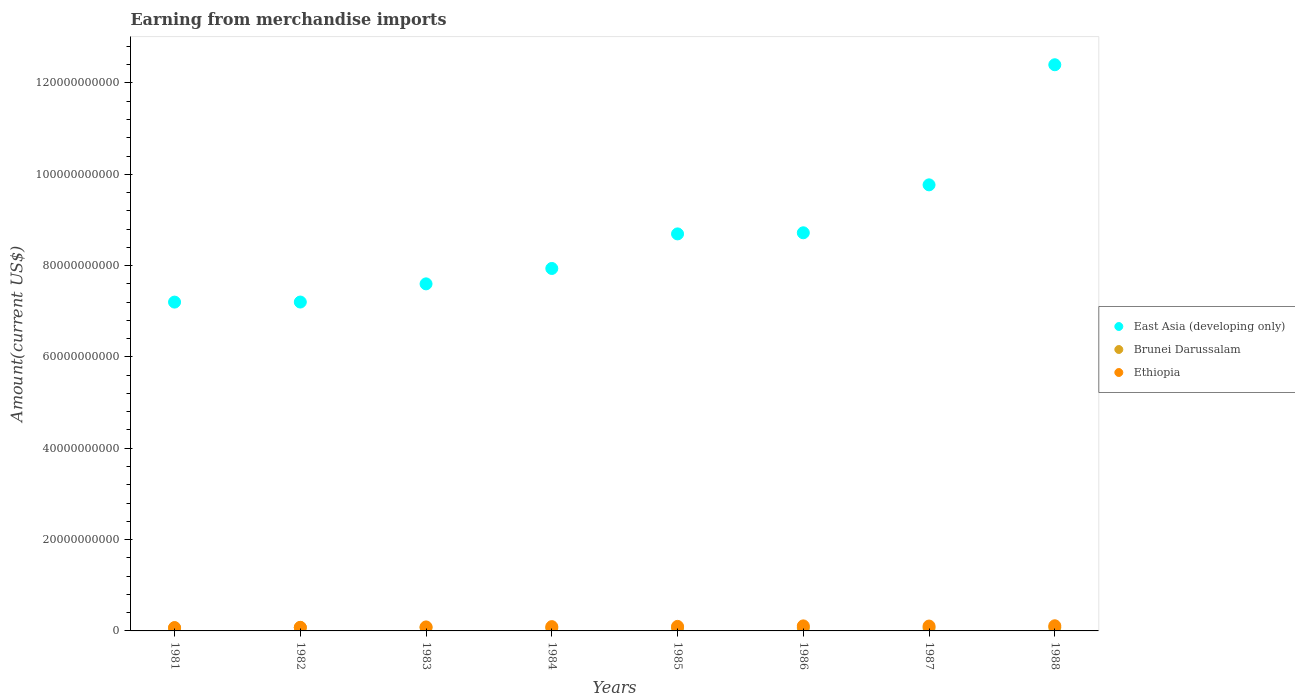How many different coloured dotlines are there?
Provide a short and direct response. 3. What is the amount earned from merchandise imports in East Asia (developing only) in 1982?
Your answer should be compact. 7.20e+1. Across all years, what is the maximum amount earned from merchandise imports in Ethiopia?
Offer a very short reply. 1.13e+09. Across all years, what is the minimum amount earned from merchandise imports in Ethiopia?
Make the answer very short. 7.39e+08. In which year was the amount earned from merchandise imports in Brunei Darussalam maximum?
Your answer should be compact. 1988. In which year was the amount earned from merchandise imports in Ethiopia minimum?
Your response must be concise. 1981. What is the total amount earned from merchandise imports in Ethiopia in the graph?
Your answer should be very brief. 7.63e+09. What is the difference between the amount earned from merchandise imports in Brunei Darussalam in 1981 and that in 1983?
Make the answer very short. -1.30e+08. What is the difference between the amount earned from merchandise imports in East Asia (developing only) in 1984 and the amount earned from merchandise imports in Brunei Darussalam in 1983?
Provide a short and direct response. 7.86e+1. What is the average amount earned from merchandise imports in Ethiopia per year?
Your answer should be very brief. 9.54e+08. In the year 1981, what is the difference between the amount earned from merchandise imports in Brunei Darussalam and amount earned from merchandise imports in East Asia (developing only)?
Your answer should be compact. -7.14e+1. In how many years, is the amount earned from merchandise imports in Brunei Darussalam greater than 16000000000 US$?
Offer a very short reply. 0. What is the ratio of the amount earned from merchandise imports in Brunei Darussalam in 1981 to that in 1983?
Offer a terse response. 0.82. What is the difference between the highest and the second highest amount earned from merchandise imports in East Asia (developing only)?
Offer a very short reply. 2.63e+1. What is the difference between the highest and the lowest amount earned from merchandise imports in Brunei Darussalam?
Your answer should be very brief. 1.50e+08. Is the sum of the amount earned from merchandise imports in East Asia (developing only) in 1981 and 1983 greater than the maximum amount earned from merchandise imports in Ethiopia across all years?
Offer a terse response. Yes. Is it the case that in every year, the sum of the amount earned from merchandise imports in Ethiopia and amount earned from merchandise imports in East Asia (developing only)  is greater than the amount earned from merchandise imports in Brunei Darussalam?
Your answer should be compact. Yes. Is the amount earned from merchandise imports in Brunei Darussalam strictly greater than the amount earned from merchandise imports in Ethiopia over the years?
Your response must be concise. No. Does the graph contain grids?
Provide a succinct answer. No. How are the legend labels stacked?
Provide a succinct answer. Vertical. What is the title of the graph?
Make the answer very short. Earning from merchandise imports. What is the label or title of the X-axis?
Your answer should be compact. Years. What is the label or title of the Y-axis?
Keep it short and to the point. Amount(current US$). What is the Amount(current US$) of East Asia (developing only) in 1981?
Provide a succinct answer. 7.20e+1. What is the Amount(current US$) of Brunei Darussalam in 1981?
Keep it short and to the point. 5.94e+08. What is the Amount(current US$) of Ethiopia in 1981?
Provide a short and direct response. 7.39e+08. What is the Amount(current US$) in East Asia (developing only) in 1982?
Your answer should be compact. 7.20e+1. What is the Amount(current US$) of Brunei Darussalam in 1982?
Give a very brief answer. 7.31e+08. What is the Amount(current US$) in Ethiopia in 1982?
Your response must be concise. 7.86e+08. What is the Amount(current US$) of East Asia (developing only) in 1983?
Offer a terse response. 7.60e+1. What is the Amount(current US$) of Brunei Darussalam in 1983?
Offer a very short reply. 7.24e+08. What is the Amount(current US$) in Ethiopia in 1983?
Ensure brevity in your answer.  8.75e+08. What is the Amount(current US$) in East Asia (developing only) in 1984?
Keep it short and to the point. 7.94e+1. What is the Amount(current US$) of Brunei Darussalam in 1984?
Provide a short and direct response. 6.26e+08. What is the Amount(current US$) of Ethiopia in 1984?
Provide a succinct answer. 9.42e+08. What is the Amount(current US$) in East Asia (developing only) in 1985?
Give a very brief answer. 8.69e+1. What is the Amount(current US$) in Brunei Darussalam in 1985?
Provide a succinct answer. 6.15e+08. What is the Amount(current US$) in Ethiopia in 1985?
Offer a terse response. 9.93e+08. What is the Amount(current US$) of East Asia (developing only) in 1986?
Provide a succinct answer. 8.72e+1. What is the Amount(current US$) of Brunei Darussalam in 1986?
Offer a very short reply. 6.56e+08. What is the Amount(current US$) of Ethiopia in 1986?
Your answer should be very brief. 1.10e+09. What is the Amount(current US$) of East Asia (developing only) in 1987?
Your answer should be very brief. 9.77e+1. What is the Amount(current US$) of Brunei Darussalam in 1987?
Give a very brief answer. 6.41e+08. What is the Amount(current US$) in Ethiopia in 1987?
Your answer should be compact. 1.07e+09. What is the Amount(current US$) of East Asia (developing only) in 1988?
Keep it short and to the point. 1.24e+11. What is the Amount(current US$) of Brunei Darussalam in 1988?
Your response must be concise. 7.44e+08. What is the Amount(current US$) of Ethiopia in 1988?
Your answer should be compact. 1.13e+09. Across all years, what is the maximum Amount(current US$) of East Asia (developing only)?
Ensure brevity in your answer.  1.24e+11. Across all years, what is the maximum Amount(current US$) of Brunei Darussalam?
Your answer should be very brief. 7.44e+08. Across all years, what is the maximum Amount(current US$) of Ethiopia?
Make the answer very short. 1.13e+09. Across all years, what is the minimum Amount(current US$) in East Asia (developing only)?
Provide a succinct answer. 7.20e+1. Across all years, what is the minimum Amount(current US$) of Brunei Darussalam?
Offer a very short reply. 5.94e+08. Across all years, what is the minimum Amount(current US$) of Ethiopia?
Make the answer very short. 7.39e+08. What is the total Amount(current US$) of East Asia (developing only) in the graph?
Your response must be concise. 6.95e+11. What is the total Amount(current US$) in Brunei Darussalam in the graph?
Your response must be concise. 5.33e+09. What is the total Amount(current US$) of Ethiopia in the graph?
Keep it short and to the point. 7.63e+09. What is the difference between the Amount(current US$) of East Asia (developing only) in 1981 and that in 1982?
Your answer should be compact. -1.40e+07. What is the difference between the Amount(current US$) of Brunei Darussalam in 1981 and that in 1982?
Offer a terse response. -1.37e+08. What is the difference between the Amount(current US$) of Ethiopia in 1981 and that in 1982?
Provide a succinct answer. -4.70e+07. What is the difference between the Amount(current US$) of East Asia (developing only) in 1981 and that in 1983?
Offer a very short reply. -3.99e+09. What is the difference between the Amount(current US$) of Brunei Darussalam in 1981 and that in 1983?
Ensure brevity in your answer.  -1.30e+08. What is the difference between the Amount(current US$) in Ethiopia in 1981 and that in 1983?
Offer a terse response. -1.36e+08. What is the difference between the Amount(current US$) of East Asia (developing only) in 1981 and that in 1984?
Offer a terse response. -7.37e+09. What is the difference between the Amount(current US$) in Brunei Darussalam in 1981 and that in 1984?
Give a very brief answer. -3.20e+07. What is the difference between the Amount(current US$) of Ethiopia in 1981 and that in 1984?
Your answer should be very brief. -2.03e+08. What is the difference between the Amount(current US$) in East Asia (developing only) in 1981 and that in 1985?
Provide a succinct answer. -1.49e+1. What is the difference between the Amount(current US$) of Brunei Darussalam in 1981 and that in 1985?
Keep it short and to the point. -2.10e+07. What is the difference between the Amount(current US$) of Ethiopia in 1981 and that in 1985?
Make the answer very short. -2.54e+08. What is the difference between the Amount(current US$) in East Asia (developing only) in 1981 and that in 1986?
Keep it short and to the point. -1.52e+1. What is the difference between the Amount(current US$) of Brunei Darussalam in 1981 and that in 1986?
Keep it short and to the point. -6.20e+07. What is the difference between the Amount(current US$) in Ethiopia in 1981 and that in 1986?
Your response must be concise. -3.63e+08. What is the difference between the Amount(current US$) in East Asia (developing only) in 1981 and that in 1987?
Offer a very short reply. -2.57e+1. What is the difference between the Amount(current US$) of Brunei Darussalam in 1981 and that in 1987?
Ensure brevity in your answer.  -4.70e+07. What is the difference between the Amount(current US$) in Ethiopia in 1981 and that in 1987?
Keep it short and to the point. -3.27e+08. What is the difference between the Amount(current US$) of East Asia (developing only) in 1981 and that in 1988?
Offer a terse response. -5.20e+1. What is the difference between the Amount(current US$) in Brunei Darussalam in 1981 and that in 1988?
Offer a very short reply. -1.50e+08. What is the difference between the Amount(current US$) in Ethiopia in 1981 and that in 1988?
Give a very brief answer. -3.90e+08. What is the difference between the Amount(current US$) of East Asia (developing only) in 1982 and that in 1983?
Your answer should be compact. -3.98e+09. What is the difference between the Amount(current US$) of Brunei Darussalam in 1982 and that in 1983?
Your response must be concise. 7.00e+06. What is the difference between the Amount(current US$) in Ethiopia in 1982 and that in 1983?
Your answer should be very brief. -8.90e+07. What is the difference between the Amount(current US$) in East Asia (developing only) in 1982 and that in 1984?
Offer a terse response. -7.35e+09. What is the difference between the Amount(current US$) of Brunei Darussalam in 1982 and that in 1984?
Provide a short and direct response. 1.05e+08. What is the difference between the Amount(current US$) of Ethiopia in 1982 and that in 1984?
Make the answer very short. -1.56e+08. What is the difference between the Amount(current US$) of East Asia (developing only) in 1982 and that in 1985?
Provide a short and direct response. -1.49e+1. What is the difference between the Amount(current US$) of Brunei Darussalam in 1982 and that in 1985?
Offer a very short reply. 1.16e+08. What is the difference between the Amount(current US$) in Ethiopia in 1982 and that in 1985?
Your answer should be compact. -2.07e+08. What is the difference between the Amount(current US$) of East Asia (developing only) in 1982 and that in 1986?
Provide a succinct answer. -1.52e+1. What is the difference between the Amount(current US$) in Brunei Darussalam in 1982 and that in 1986?
Offer a terse response. 7.50e+07. What is the difference between the Amount(current US$) of Ethiopia in 1982 and that in 1986?
Provide a short and direct response. -3.16e+08. What is the difference between the Amount(current US$) of East Asia (developing only) in 1982 and that in 1987?
Ensure brevity in your answer.  -2.57e+1. What is the difference between the Amount(current US$) of Brunei Darussalam in 1982 and that in 1987?
Your response must be concise. 9.00e+07. What is the difference between the Amount(current US$) in Ethiopia in 1982 and that in 1987?
Your answer should be compact. -2.80e+08. What is the difference between the Amount(current US$) in East Asia (developing only) in 1982 and that in 1988?
Offer a very short reply. -5.20e+1. What is the difference between the Amount(current US$) in Brunei Darussalam in 1982 and that in 1988?
Ensure brevity in your answer.  -1.30e+07. What is the difference between the Amount(current US$) in Ethiopia in 1982 and that in 1988?
Offer a very short reply. -3.43e+08. What is the difference between the Amount(current US$) in East Asia (developing only) in 1983 and that in 1984?
Your answer should be very brief. -3.37e+09. What is the difference between the Amount(current US$) of Brunei Darussalam in 1983 and that in 1984?
Provide a succinct answer. 9.80e+07. What is the difference between the Amount(current US$) in Ethiopia in 1983 and that in 1984?
Your response must be concise. -6.70e+07. What is the difference between the Amount(current US$) in East Asia (developing only) in 1983 and that in 1985?
Keep it short and to the point. -1.09e+1. What is the difference between the Amount(current US$) in Brunei Darussalam in 1983 and that in 1985?
Keep it short and to the point. 1.09e+08. What is the difference between the Amount(current US$) of Ethiopia in 1983 and that in 1985?
Offer a very short reply. -1.18e+08. What is the difference between the Amount(current US$) in East Asia (developing only) in 1983 and that in 1986?
Provide a succinct answer. -1.12e+1. What is the difference between the Amount(current US$) in Brunei Darussalam in 1983 and that in 1986?
Offer a terse response. 6.80e+07. What is the difference between the Amount(current US$) of Ethiopia in 1983 and that in 1986?
Provide a short and direct response. -2.27e+08. What is the difference between the Amount(current US$) of East Asia (developing only) in 1983 and that in 1987?
Offer a very short reply. -2.17e+1. What is the difference between the Amount(current US$) of Brunei Darussalam in 1983 and that in 1987?
Keep it short and to the point. 8.30e+07. What is the difference between the Amount(current US$) of Ethiopia in 1983 and that in 1987?
Make the answer very short. -1.91e+08. What is the difference between the Amount(current US$) in East Asia (developing only) in 1983 and that in 1988?
Offer a terse response. -4.80e+1. What is the difference between the Amount(current US$) of Brunei Darussalam in 1983 and that in 1988?
Offer a very short reply. -2.00e+07. What is the difference between the Amount(current US$) of Ethiopia in 1983 and that in 1988?
Offer a terse response. -2.54e+08. What is the difference between the Amount(current US$) in East Asia (developing only) in 1984 and that in 1985?
Keep it short and to the point. -7.57e+09. What is the difference between the Amount(current US$) in Brunei Darussalam in 1984 and that in 1985?
Your answer should be compact. 1.10e+07. What is the difference between the Amount(current US$) of Ethiopia in 1984 and that in 1985?
Ensure brevity in your answer.  -5.10e+07. What is the difference between the Amount(current US$) in East Asia (developing only) in 1984 and that in 1986?
Make the answer very short. -7.81e+09. What is the difference between the Amount(current US$) of Brunei Darussalam in 1984 and that in 1986?
Offer a very short reply. -3.00e+07. What is the difference between the Amount(current US$) in Ethiopia in 1984 and that in 1986?
Provide a succinct answer. -1.60e+08. What is the difference between the Amount(current US$) of East Asia (developing only) in 1984 and that in 1987?
Your answer should be compact. -1.83e+1. What is the difference between the Amount(current US$) of Brunei Darussalam in 1984 and that in 1987?
Offer a very short reply. -1.50e+07. What is the difference between the Amount(current US$) of Ethiopia in 1984 and that in 1987?
Give a very brief answer. -1.24e+08. What is the difference between the Amount(current US$) in East Asia (developing only) in 1984 and that in 1988?
Keep it short and to the point. -4.46e+1. What is the difference between the Amount(current US$) in Brunei Darussalam in 1984 and that in 1988?
Provide a short and direct response. -1.18e+08. What is the difference between the Amount(current US$) in Ethiopia in 1984 and that in 1988?
Provide a short and direct response. -1.87e+08. What is the difference between the Amount(current US$) of East Asia (developing only) in 1985 and that in 1986?
Make the answer very short. -2.43e+08. What is the difference between the Amount(current US$) in Brunei Darussalam in 1985 and that in 1986?
Your answer should be compact. -4.10e+07. What is the difference between the Amount(current US$) of Ethiopia in 1985 and that in 1986?
Offer a terse response. -1.09e+08. What is the difference between the Amount(current US$) of East Asia (developing only) in 1985 and that in 1987?
Give a very brief answer. -1.07e+1. What is the difference between the Amount(current US$) in Brunei Darussalam in 1985 and that in 1987?
Keep it short and to the point. -2.60e+07. What is the difference between the Amount(current US$) of Ethiopia in 1985 and that in 1987?
Keep it short and to the point. -7.30e+07. What is the difference between the Amount(current US$) in East Asia (developing only) in 1985 and that in 1988?
Give a very brief answer. -3.70e+1. What is the difference between the Amount(current US$) in Brunei Darussalam in 1985 and that in 1988?
Your response must be concise. -1.29e+08. What is the difference between the Amount(current US$) in Ethiopia in 1985 and that in 1988?
Provide a succinct answer. -1.36e+08. What is the difference between the Amount(current US$) of East Asia (developing only) in 1986 and that in 1987?
Your answer should be compact. -1.05e+1. What is the difference between the Amount(current US$) of Brunei Darussalam in 1986 and that in 1987?
Your answer should be compact. 1.50e+07. What is the difference between the Amount(current US$) in Ethiopia in 1986 and that in 1987?
Make the answer very short. 3.60e+07. What is the difference between the Amount(current US$) of East Asia (developing only) in 1986 and that in 1988?
Your response must be concise. -3.68e+1. What is the difference between the Amount(current US$) in Brunei Darussalam in 1986 and that in 1988?
Your response must be concise. -8.80e+07. What is the difference between the Amount(current US$) of Ethiopia in 1986 and that in 1988?
Make the answer very short. -2.70e+07. What is the difference between the Amount(current US$) of East Asia (developing only) in 1987 and that in 1988?
Your answer should be very brief. -2.63e+1. What is the difference between the Amount(current US$) of Brunei Darussalam in 1987 and that in 1988?
Offer a terse response. -1.03e+08. What is the difference between the Amount(current US$) in Ethiopia in 1987 and that in 1988?
Your response must be concise. -6.30e+07. What is the difference between the Amount(current US$) in East Asia (developing only) in 1981 and the Amount(current US$) in Brunei Darussalam in 1982?
Provide a short and direct response. 7.13e+1. What is the difference between the Amount(current US$) of East Asia (developing only) in 1981 and the Amount(current US$) of Ethiopia in 1982?
Ensure brevity in your answer.  7.12e+1. What is the difference between the Amount(current US$) of Brunei Darussalam in 1981 and the Amount(current US$) of Ethiopia in 1982?
Your answer should be compact. -1.92e+08. What is the difference between the Amount(current US$) of East Asia (developing only) in 1981 and the Amount(current US$) of Brunei Darussalam in 1983?
Give a very brief answer. 7.13e+1. What is the difference between the Amount(current US$) in East Asia (developing only) in 1981 and the Amount(current US$) in Ethiopia in 1983?
Offer a terse response. 7.11e+1. What is the difference between the Amount(current US$) in Brunei Darussalam in 1981 and the Amount(current US$) in Ethiopia in 1983?
Make the answer very short. -2.81e+08. What is the difference between the Amount(current US$) of East Asia (developing only) in 1981 and the Amount(current US$) of Brunei Darussalam in 1984?
Offer a very short reply. 7.14e+1. What is the difference between the Amount(current US$) of East Asia (developing only) in 1981 and the Amount(current US$) of Ethiopia in 1984?
Offer a terse response. 7.11e+1. What is the difference between the Amount(current US$) of Brunei Darussalam in 1981 and the Amount(current US$) of Ethiopia in 1984?
Offer a terse response. -3.48e+08. What is the difference between the Amount(current US$) in East Asia (developing only) in 1981 and the Amount(current US$) in Brunei Darussalam in 1985?
Give a very brief answer. 7.14e+1. What is the difference between the Amount(current US$) in East Asia (developing only) in 1981 and the Amount(current US$) in Ethiopia in 1985?
Give a very brief answer. 7.10e+1. What is the difference between the Amount(current US$) in Brunei Darussalam in 1981 and the Amount(current US$) in Ethiopia in 1985?
Keep it short and to the point. -3.99e+08. What is the difference between the Amount(current US$) of East Asia (developing only) in 1981 and the Amount(current US$) of Brunei Darussalam in 1986?
Keep it short and to the point. 7.13e+1. What is the difference between the Amount(current US$) in East Asia (developing only) in 1981 and the Amount(current US$) in Ethiopia in 1986?
Provide a short and direct response. 7.09e+1. What is the difference between the Amount(current US$) of Brunei Darussalam in 1981 and the Amount(current US$) of Ethiopia in 1986?
Ensure brevity in your answer.  -5.08e+08. What is the difference between the Amount(current US$) of East Asia (developing only) in 1981 and the Amount(current US$) of Brunei Darussalam in 1987?
Keep it short and to the point. 7.14e+1. What is the difference between the Amount(current US$) of East Asia (developing only) in 1981 and the Amount(current US$) of Ethiopia in 1987?
Your answer should be very brief. 7.09e+1. What is the difference between the Amount(current US$) of Brunei Darussalam in 1981 and the Amount(current US$) of Ethiopia in 1987?
Provide a short and direct response. -4.72e+08. What is the difference between the Amount(current US$) of East Asia (developing only) in 1981 and the Amount(current US$) of Brunei Darussalam in 1988?
Offer a terse response. 7.13e+1. What is the difference between the Amount(current US$) of East Asia (developing only) in 1981 and the Amount(current US$) of Ethiopia in 1988?
Your answer should be very brief. 7.09e+1. What is the difference between the Amount(current US$) in Brunei Darussalam in 1981 and the Amount(current US$) in Ethiopia in 1988?
Your answer should be compact. -5.35e+08. What is the difference between the Amount(current US$) of East Asia (developing only) in 1982 and the Amount(current US$) of Brunei Darussalam in 1983?
Make the answer very short. 7.13e+1. What is the difference between the Amount(current US$) of East Asia (developing only) in 1982 and the Amount(current US$) of Ethiopia in 1983?
Provide a short and direct response. 7.11e+1. What is the difference between the Amount(current US$) of Brunei Darussalam in 1982 and the Amount(current US$) of Ethiopia in 1983?
Offer a terse response. -1.44e+08. What is the difference between the Amount(current US$) of East Asia (developing only) in 1982 and the Amount(current US$) of Brunei Darussalam in 1984?
Your response must be concise. 7.14e+1. What is the difference between the Amount(current US$) of East Asia (developing only) in 1982 and the Amount(current US$) of Ethiopia in 1984?
Offer a very short reply. 7.11e+1. What is the difference between the Amount(current US$) of Brunei Darussalam in 1982 and the Amount(current US$) of Ethiopia in 1984?
Offer a terse response. -2.11e+08. What is the difference between the Amount(current US$) of East Asia (developing only) in 1982 and the Amount(current US$) of Brunei Darussalam in 1985?
Offer a very short reply. 7.14e+1. What is the difference between the Amount(current US$) of East Asia (developing only) in 1982 and the Amount(current US$) of Ethiopia in 1985?
Your answer should be very brief. 7.10e+1. What is the difference between the Amount(current US$) in Brunei Darussalam in 1982 and the Amount(current US$) in Ethiopia in 1985?
Offer a terse response. -2.62e+08. What is the difference between the Amount(current US$) of East Asia (developing only) in 1982 and the Amount(current US$) of Brunei Darussalam in 1986?
Your response must be concise. 7.14e+1. What is the difference between the Amount(current US$) of East Asia (developing only) in 1982 and the Amount(current US$) of Ethiopia in 1986?
Your response must be concise. 7.09e+1. What is the difference between the Amount(current US$) of Brunei Darussalam in 1982 and the Amount(current US$) of Ethiopia in 1986?
Your response must be concise. -3.71e+08. What is the difference between the Amount(current US$) in East Asia (developing only) in 1982 and the Amount(current US$) in Brunei Darussalam in 1987?
Your answer should be compact. 7.14e+1. What is the difference between the Amount(current US$) in East Asia (developing only) in 1982 and the Amount(current US$) in Ethiopia in 1987?
Ensure brevity in your answer.  7.10e+1. What is the difference between the Amount(current US$) in Brunei Darussalam in 1982 and the Amount(current US$) in Ethiopia in 1987?
Your answer should be compact. -3.35e+08. What is the difference between the Amount(current US$) of East Asia (developing only) in 1982 and the Amount(current US$) of Brunei Darussalam in 1988?
Keep it short and to the point. 7.13e+1. What is the difference between the Amount(current US$) of East Asia (developing only) in 1982 and the Amount(current US$) of Ethiopia in 1988?
Provide a succinct answer. 7.09e+1. What is the difference between the Amount(current US$) of Brunei Darussalam in 1982 and the Amount(current US$) of Ethiopia in 1988?
Offer a very short reply. -3.98e+08. What is the difference between the Amount(current US$) in East Asia (developing only) in 1983 and the Amount(current US$) in Brunei Darussalam in 1984?
Provide a succinct answer. 7.54e+1. What is the difference between the Amount(current US$) of East Asia (developing only) in 1983 and the Amount(current US$) of Ethiopia in 1984?
Make the answer very short. 7.51e+1. What is the difference between the Amount(current US$) in Brunei Darussalam in 1983 and the Amount(current US$) in Ethiopia in 1984?
Keep it short and to the point. -2.18e+08. What is the difference between the Amount(current US$) in East Asia (developing only) in 1983 and the Amount(current US$) in Brunei Darussalam in 1985?
Offer a very short reply. 7.54e+1. What is the difference between the Amount(current US$) in East Asia (developing only) in 1983 and the Amount(current US$) in Ethiopia in 1985?
Offer a terse response. 7.50e+1. What is the difference between the Amount(current US$) in Brunei Darussalam in 1983 and the Amount(current US$) in Ethiopia in 1985?
Provide a short and direct response. -2.69e+08. What is the difference between the Amount(current US$) in East Asia (developing only) in 1983 and the Amount(current US$) in Brunei Darussalam in 1986?
Keep it short and to the point. 7.53e+1. What is the difference between the Amount(current US$) of East Asia (developing only) in 1983 and the Amount(current US$) of Ethiopia in 1986?
Provide a succinct answer. 7.49e+1. What is the difference between the Amount(current US$) of Brunei Darussalam in 1983 and the Amount(current US$) of Ethiopia in 1986?
Offer a very short reply. -3.78e+08. What is the difference between the Amount(current US$) in East Asia (developing only) in 1983 and the Amount(current US$) in Brunei Darussalam in 1987?
Your answer should be very brief. 7.54e+1. What is the difference between the Amount(current US$) in East Asia (developing only) in 1983 and the Amount(current US$) in Ethiopia in 1987?
Offer a terse response. 7.49e+1. What is the difference between the Amount(current US$) of Brunei Darussalam in 1983 and the Amount(current US$) of Ethiopia in 1987?
Make the answer very short. -3.42e+08. What is the difference between the Amount(current US$) in East Asia (developing only) in 1983 and the Amount(current US$) in Brunei Darussalam in 1988?
Offer a very short reply. 7.53e+1. What is the difference between the Amount(current US$) of East Asia (developing only) in 1983 and the Amount(current US$) of Ethiopia in 1988?
Your response must be concise. 7.49e+1. What is the difference between the Amount(current US$) of Brunei Darussalam in 1983 and the Amount(current US$) of Ethiopia in 1988?
Your response must be concise. -4.05e+08. What is the difference between the Amount(current US$) in East Asia (developing only) in 1984 and the Amount(current US$) in Brunei Darussalam in 1985?
Your answer should be very brief. 7.88e+1. What is the difference between the Amount(current US$) in East Asia (developing only) in 1984 and the Amount(current US$) in Ethiopia in 1985?
Offer a terse response. 7.84e+1. What is the difference between the Amount(current US$) of Brunei Darussalam in 1984 and the Amount(current US$) of Ethiopia in 1985?
Provide a short and direct response. -3.67e+08. What is the difference between the Amount(current US$) in East Asia (developing only) in 1984 and the Amount(current US$) in Brunei Darussalam in 1986?
Your answer should be compact. 7.87e+1. What is the difference between the Amount(current US$) in East Asia (developing only) in 1984 and the Amount(current US$) in Ethiopia in 1986?
Keep it short and to the point. 7.83e+1. What is the difference between the Amount(current US$) of Brunei Darussalam in 1984 and the Amount(current US$) of Ethiopia in 1986?
Provide a succinct answer. -4.76e+08. What is the difference between the Amount(current US$) of East Asia (developing only) in 1984 and the Amount(current US$) of Brunei Darussalam in 1987?
Ensure brevity in your answer.  7.87e+1. What is the difference between the Amount(current US$) of East Asia (developing only) in 1984 and the Amount(current US$) of Ethiopia in 1987?
Ensure brevity in your answer.  7.83e+1. What is the difference between the Amount(current US$) of Brunei Darussalam in 1984 and the Amount(current US$) of Ethiopia in 1987?
Provide a succinct answer. -4.40e+08. What is the difference between the Amount(current US$) in East Asia (developing only) in 1984 and the Amount(current US$) in Brunei Darussalam in 1988?
Your response must be concise. 7.86e+1. What is the difference between the Amount(current US$) of East Asia (developing only) in 1984 and the Amount(current US$) of Ethiopia in 1988?
Your answer should be very brief. 7.82e+1. What is the difference between the Amount(current US$) in Brunei Darussalam in 1984 and the Amount(current US$) in Ethiopia in 1988?
Ensure brevity in your answer.  -5.03e+08. What is the difference between the Amount(current US$) of East Asia (developing only) in 1985 and the Amount(current US$) of Brunei Darussalam in 1986?
Your response must be concise. 8.63e+1. What is the difference between the Amount(current US$) of East Asia (developing only) in 1985 and the Amount(current US$) of Ethiopia in 1986?
Offer a terse response. 8.58e+1. What is the difference between the Amount(current US$) in Brunei Darussalam in 1985 and the Amount(current US$) in Ethiopia in 1986?
Give a very brief answer. -4.87e+08. What is the difference between the Amount(current US$) in East Asia (developing only) in 1985 and the Amount(current US$) in Brunei Darussalam in 1987?
Offer a terse response. 8.63e+1. What is the difference between the Amount(current US$) of East Asia (developing only) in 1985 and the Amount(current US$) of Ethiopia in 1987?
Ensure brevity in your answer.  8.59e+1. What is the difference between the Amount(current US$) in Brunei Darussalam in 1985 and the Amount(current US$) in Ethiopia in 1987?
Your answer should be compact. -4.51e+08. What is the difference between the Amount(current US$) of East Asia (developing only) in 1985 and the Amount(current US$) of Brunei Darussalam in 1988?
Provide a short and direct response. 8.62e+1. What is the difference between the Amount(current US$) in East Asia (developing only) in 1985 and the Amount(current US$) in Ethiopia in 1988?
Your response must be concise. 8.58e+1. What is the difference between the Amount(current US$) in Brunei Darussalam in 1985 and the Amount(current US$) in Ethiopia in 1988?
Ensure brevity in your answer.  -5.14e+08. What is the difference between the Amount(current US$) of East Asia (developing only) in 1986 and the Amount(current US$) of Brunei Darussalam in 1987?
Make the answer very short. 8.65e+1. What is the difference between the Amount(current US$) of East Asia (developing only) in 1986 and the Amount(current US$) of Ethiopia in 1987?
Provide a short and direct response. 8.61e+1. What is the difference between the Amount(current US$) of Brunei Darussalam in 1986 and the Amount(current US$) of Ethiopia in 1987?
Your answer should be very brief. -4.10e+08. What is the difference between the Amount(current US$) in East Asia (developing only) in 1986 and the Amount(current US$) in Brunei Darussalam in 1988?
Provide a short and direct response. 8.64e+1. What is the difference between the Amount(current US$) of East Asia (developing only) in 1986 and the Amount(current US$) of Ethiopia in 1988?
Your response must be concise. 8.61e+1. What is the difference between the Amount(current US$) in Brunei Darussalam in 1986 and the Amount(current US$) in Ethiopia in 1988?
Make the answer very short. -4.73e+08. What is the difference between the Amount(current US$) of East Asia (developing only) in 1987 and the Amount(current US$) of Brunei Darussalam in 1988?
Keep it short and to the point. 9.69e+1. What is the difference between the Amount(current US$) in East Asia (developing only) in 1987 and the Amount(current US$) in Ethiopia in 1988?
Offer a terse response. 9.66e+1. What is the difference between the Amount(current US$) of Brunei Darussalam in 1987 and the Amount(current US$) of Ethiopia in 1988?
Your answer should be compact. -4.88e+08. What is the average Amount(current US$) of East Asia (developing only) per year?
Your answer should be very brief. 8.69e+1. What is the average Amount(current US$) in Brunei Darussalam per year?
Your response must be concise. 6.66e+08. What is the average Amount(current US$) in Ethiopia per year?
Give a very brief answer. 9.54e+08. In the year 1981, what is the difference between the Amount(current US$) of East Asia (developing only) and Amount(current US$) of Brunei Darussalam?
Give a very brief answer. 7.14e+1. In the year 1981, what is the difference between the Amount(current US$) in East Asia (developing only) and Amount(current US$) in Ethiopia?
Your answer should be very brief. 7.13e+1. In the year 1981, what is the difference between the Amount(current US$) of Brunei Darussalam and Amount(current US$) of Ethiopia?
Keep it short and to the point. -1.45e+08. In the year 1982, what is the difference between the Amount(current US$) of East Asia (developing only) and Amount(current US$) of Brunei Darussalam?
Keep it short and to the point. 7.13e+1. In the year 1982, what is the difference between the Amount(current US$) of East Asia (developing only) and Amount(current US$) of Ethiopia?
Your response must be concise. 7.12e+1. In the year 1982, what is the difference between the Amount(current US$) in Brunei Darussalam and Amount(current US$) in Ethiopia?
Keep it short and to the point. -5.50e+07. In the year 1983, what is the difference between the Amount(current US$) in East Asia (developing only) and Amount(current US$) in Brunei Darussalam?
Your answer should be compact. 7.53e+1. In the year 1983, what is the difference between the Amount(current US$) of East Asia (developing only) and Amount(current US$) of Ethiopia?
Provide a succinct answer. 7.51e+1. In the year 1983, what is the difference between the Amount(current US$) in Brunei Darussalam and Amount(current US$) in Ethiopia?
Provide a short and direct response. -1.51e+08. In the year 1984, what is the difference between the Amount(current US$) in East Asia (developing only) and Amount(current US$) in Brunei Darussalam?
Make the answer very short. 7.87e+1. In the year 1984, what is the difference between the Amount(current US$) of East Asia (developing only) and Amount(current US$) of Ethiopia?
Offer a terse response. 7.84e+1. In the year 1984, what is the difference between the Amount(current US$) in Brunei Darussalam and Amount(current US$) in Ethiopia?
Ensure brevity in your answer.  -3.16e+08. In the year 1985, what is the difference between the Amount(current US$) in East Asia (developing only) and Amount(current US$) in Brunei Darussalam?
Make the answer very short. 8.63e+1. In the year 1985, what is the difference between the Amount(current US$) of East Asia (developing only) and Amount(current US$) of Ethiopia?
Keep it short and to the point. 8.59e+1. In the year 1985, what is the difference between the Amount(current US$) in Brunei Darussalam and Amount(current US$) in Ethiopia?
Your answer should be very brief. -3.78e+08. In the year 1986, what is the difference between the Amount(current US$) in East Asia (developing only) and Amount(current US$) in Brunei Darussalam?
Your answer should be compact. 8.65e+1. In the year 1986, what is the difference between the Amount(current US$) in East Asia (developing only) and Amount(current US$) in Ethiopia?
Provide a succinct answer. 8.61e+1. In the year 1986, what is the difference between the Amount(current US$) of Brunei Darussalam and Amount(current US$) of Ethiopia?
Keep it short and to the point. -4.46e+08. In the year 1987, what is the difference between the Amount(current US$) of East Asia (developing only) and Amount(current US$) of Brunei Darussalam?
Your answer should be compact. 9.70e+1. In the year 1987, what is the difference between the Amount(current US$) of East Asia (developing only) and Amount(current US$) of Ethiopia?
Provide a succinct answer. 9.66e+1. In the year 1987, what is the difference between the Amount(current US$) in Brunei Darussalam and Amount(current US$) in Ethiopia?
Your answer should be very brief. -4.25e+08. In the year 1988, what is the difference between the Amount(current US$) of East Asia (developing only) and Amount(current US$) of Brunei Darussalam?
Provide a short and direct response. 1.23e+11. In the year 1988, what is the difference between the Amount(current US$) in East Asia (developing only) and Amount(current US$) in Ethiopia?
Provide a succinct answer. 1.23e+11. In the year 1988, what is the difference between the Amount(current US$) of Brunei Darussalam and Amount(current US$) of Ethiopia?
Provide a succinct answer. -3.85e+08. What is the ratio of the Amount(current US$) of Brunei Darussalam in 1981 to that in 1982?
Offer a terse response. 0.81. What is the ratio of the Amount(current US$) of Ethiopia in 1981 to that in 1982?
Ensure brevity in your answer.  0.94. What is the ratio of the Amount(current US$) of East Asia (developing only) in 1981 to that in 1983?
Offer a terse response. 0.95. What is the ratio of the Amount(current US$) of Brunei Darussalam in 1981 to that in 1983?
Give a very brief answer. 0.82. What is the ratio of the Amount(current US$) of Ethiopia in 1981 to that in 1983?
Offer a terse response. 0.84. What is the ratio of the Amount(current US$) of East Asia (developing only) in 1981 to that in 1984?
Keep it short and to the point. 0.91. What is the ratio of the Amount(current US$) in Brunei Darussalam in 1981 to that in 1984?
Ensure brevity in your answer.  0.95. What is the ratio of the Amount(current US$) of Ethiopia in 1981 to that in 1984?
Give a very brief answer. 0.78. What is the ratio of the Amount(current US$) in East Asia (developing only) in 1981 to that in 1985?
Give a very brief answer. 0.83. What is the ratio of the Amount(current US$) of Brunei Darussalam in 1981 to that in 1985?
Your answer should be very brief. 0.97. What is the ratio of the Amount(current US$) of Ethiopia in 1981 to that in 1985?
Keep it short and to the point. 0.74. What is the ratio of the Amount(current US$) in East Asia (developing only) in 1981 to that in 1986?
Offer a very short reply. 0.83. What is the ratio of the Amount(current US$) of Brunei Darussalam in 1981 to that in 1986?
Provide a succinct answer. 0.91. What is the ratio of the Amount(current US$) of Ethiopia in 1981 to that in 1986?
Provide a short and direct response. 0.67. What is the ratio of the Amount(current US$) in East Asia (developing only) in 1981 to that in 1987?
Provide a succinct answer. 0.74. What is the ratio of the Amount(current US$) of Brunei Darussalam in 1981 to that in 1987?
Your answer should be compact. 0.93. What is the ratio of the Amount(current US$) of Ethiopia in 1981 to that in 1987?
Give a very brief answer. 0.69. What is the ratio of the Amount(current US$) of East Asia (developing only) in 1981 to that in 1988?
Keep it short and to the point. 0.58. What is the ratio of the Amount(current US$) of Brunei Darussalam in 1981 to that in 1988?
Your answer should be compact. 0.8. What is the ratio of the Amount(current US$) of Ethiopia in 1981 to that in 1988?
Offer a terse response. 0.65. What is the ratio of the Amount(current US$) in East Asia (developing only) in 1982 to that in 1983?
Make the answer very short. 0.95. What is the ratio of the Amount(current US$) of Brunei Darussalam in 1982 to that in 1983?
Your response must be concise. 1.01. What is the ratio of the Amount(current US$) of Ethiopia in 1982 to that in 1983?
Offer a terse response. 0.9. What is the ratio of the Amount(current US$) of East Asia (developing only) in 1982 to that in 1984?
Ensure brevity in your answer.  0.91. What is the ratio of the Amount(current US$) in Brunei Darussalam in 1982 to that in 1984?
Your answer should be very brief. 1.17. What is the ratio of the Amount(current US$) of Ethiopia in 1982 to that in 1984?
Your response must be concise. 0.83. What is the ratio of the Amount(current US$) in East Asia (developing only) in 1982 to that in 1985?
Your response must be concise. 0.83. What is the ratio of the Amount(current US$) of Brunei Darussalam in 1982 to that in 1985?
Your answer should be compact. 1.19. What is the ratio of the Amount(current US$) of Ethiopia in 1982 to that in 1985?
Offer a terse response. 0.79. What is the ratio of the Amount(current US$) in East Asia (developing only) in 1982 to that in 1986?
Your response must be concise. 0.83. What is the ratio of the Amount(current US$) in Brunei Darussalam in 1982 to that in 1986?
Make the answer very short. 1.11. What is the ratio of the Amount(current US$) in Ethiopia in 1982 to that in 1986?
Offer a very short reply. 0.71. What is the ratio of the Amount(current US$) in East Asia (developing only) in 1982 to that in 1987?
Your answer should be very brief. 0.74. What is the ratio of the Amount(current US$) of Brunei Darussalam in 1982 to that in 1987?
Make the answer very short. 1.14. What is the ratio of the Amount(current US$) in Ethiopia in 1982 to that in 1987?
Your response must be concise. 0.74. What is the ratio of the Amount(current US$) in East Asia (developing only) in 1982 to that in 1988?
Offer a very short reply. 0.58. What is the ratio of the Amount(current US$) of Brunei Darussalam in 1982 to that in 1988?
Your answer should be compact. 0.98. What is the ratio of the Amount(current US$) in Ethiopia in 1982 to that in 1988?
Offer a terse response. 0.7. What is the ratio of the Amount(current US$) of East Asia (developing only) in 1983 to that in 1984?
Offer a very short reply. 0.96. What is the ratio of the Amount(current US$) of Brunei Darussalam in 1983 to that in 1984?
Provide a short and direct response. 1.16. What is the ratio of the Amount(current US$) in Ethiopia in 1983 to that in 1984?
Your answer should be compact. 0.93. What is the ratio of the Amount(current US$) in East Asia (developing only) in 1983 to that in 1985?
Provide a short and direct response. 0.87. What is the ratio of the Amount(current US$) in Brunei Darussalam in 1983 to that in 1985?
Give a very brief answer. 1.18. What is the ratio of the Amount(current US$) of Ethiopia in 1983 to that in 1985?
Ensure brevity in your answer.  0.88. What is the ratio of the Amount(current US$) of East Asia (developing only) in 1983 to that in 1986?
Provide a short and direct response. 0.87. What is the ratio of the Amount(current US$) of Brunei Darussalam in 1983 to that in 1986?
Give a very brief answer. 1.1. What is the ratio of the Amount(current US$) of Ethiopia in 1983 to that in 1986?
Make the answer very short. 0.79. What is the ratio of the Amount(current US$) of East Asia (developing only) in 1983 to that in 1987?
Provide a short and direct response. 0.78. What is the ratio of the Amount(current US$) of Brunei Darussalam in 1983 to that in 1987?
Keep it short and to the point. 1.13. What is the ratio of the Amount(current US$) of Ethiopia in 1983 to that in 1987?
Provide a succinct answer. 0.82. What is the ratio of the Amount(current US$) of East Asia (developing only) in 1983 to that in 1988?
Your response must be concise. 0.61. What is the ratio of the Amount(current US$) in Brunei Darussalam in 1983 to that in 1988?
Offer a terse response. 0.97. What is the ratio of the Amount(current US$) in Ethiopia in 1983 to that in 1988?
Offer a very short reply. 0.78. What is the ratio of the Amount(current US$) in East Asia (developing only) in 1984 to that in 1985?
Give a very brief answer. 0.91. What is the ratio of the Amount(current US$) of Brunei Darussalam in 1984 to that in 1985?
Ensure brevity in your answer.  1.02. What is the ratio of the Amount(current US$) in Ethiopia in 1984 to that in 1985?
Give a very brief answer. 0.95. What is the ratio of the Amount(current US$) of East Asia (developing only) in 1984 to that in 1986?
Your answer should be compact. 0.91. What is the ratio of the Amount(current US$) of Brunei Darussalam in 1984 to that in 1986?
Keep it short and to the point. 0.95. What is the ratio of the Amount(current US$) of Ethiopia in 1984 to that in 1986?
Your response must be concise. 0.85. What is the ratio of the Amount(current US$) in East Asia (developing only) in 1984 to that in 1987?
Give a very brief answer. 0.81. What is the ratio of the Amount(current US$) in Brunei Darussalam in 1984 to that in 1987?
Ensure brevity in your answer.  0.98. What is the ratio of the Amount(current US$) of Ethiopia in 1984 to that in 1987?
Your response must be concise. 0.88. What is the ratio of the Amount(current US$) in East Asia (developing only) in 1984 to that in 1988?
Give a very brief answer. 0.64. What is the ratio of the Amount(current US$) of Brunei Darussalam in 1984 to that in 1988?
Provide a succinct answer. 0.84. What is the ratio of the Amount(current US$) of Ethiopia in 1984 to that in 1988?
Your response must be concise. 0.83. What is the ratio of the Amount(current US$) of Ethiopia in 1985 to that in 1986?
Provide a succinct answer. 0.9. What is the ratio of the Amount(current US$) in East Asia (developing only) in 1985 to that in 1987?
Provide a short and direct response. 0.89. What is the ratio of the Amount(current US$) in Brunei Darussalam in 1985 to that in 1987?
Your response must be concise. 0.96. What is the ratio of the Amount(current US$) of Ethiopia in 1985 to that in 1987?
Your answer should be compact. 0.93. What is the ratio of the Amount(current US$) of East Asia (developing only) in 1985 to that in 1988?
Make the answer very short. 0.7. What is the ratio of the Amount(current US$) in Brunei Darussalam in 1985 to that in 1988?
Keep it short and to the point. 0.83. What is the ratio of the Amount(current US$) in Ethiopia in 1985 to that in 1988?
Your response must be concise. 0.88. What is the ratio of the Amount(current US$) in East Asia (developing only) in 1986 to that in 1987?
Offer a terse response. 0.89. What is the ratio of the Amount(current US$) in Brunei Darussalam in 1986 to that in 1987?
Offer a terse response. 1.02. What is the ratio of the Amount(current US$) of Ethiopia in 1986 to that in 1987?
Your answer should be very brief. 1.03. What is the ratio of the Amount(current US$) in East Asia (developing only) in 1986 to that in 1988?
Make the answer very short. 0.7. What is the ratio of the Amount(current US$) in Brunei Darussalam in 1986 to that in 1988?
Give a very brief answer. 0.88. What is the ratio of the Amount(current US$) of Ethiopia in 1986 to that in 1988?
Your answer should be compact. 0.98. What is the ratio of the Amount(current US$) in East Asia (developing only) in 1987 to that in 1988?
Offer a very short reply. 0.79. What is the ratio of the Amount(current US$) in Brunei Darussalam in 1987 to that in 1988?
Your answer should be compact. 0.86. What is the ratio of the Amount(current US$) of Ethiopia in 1987 to that in 1988?
Keep it short and to the point. 0.94. What is the difference between the highest and the second highest Amount(current US$) of East Asia (developing only)?
Your answer should be compact. 2.63e+1. What is the difference between the highest and the second highest Amount(current US$) of Brunei Darussalam?
Your answer should be very brief. 1.30e+07. What is the difference between the highest and the second highest Amount(current US$) in Ethiopia?
Your answer should be very brief. 2.70e+07. What is the difference between the highest and the lowest Amount(current US$) in East Asia (developing only)?
Your response must be concise. 5.20e+1. What is the difference between the highest and the lowest Amount(current US$) in Brunei Darussalam?
Offer a very short reply. 1.50e+08. What is the difference between the highest and the lowest Amount(current US$) of Ethiopia?
Offer a very short reply. 3.90e+08. 